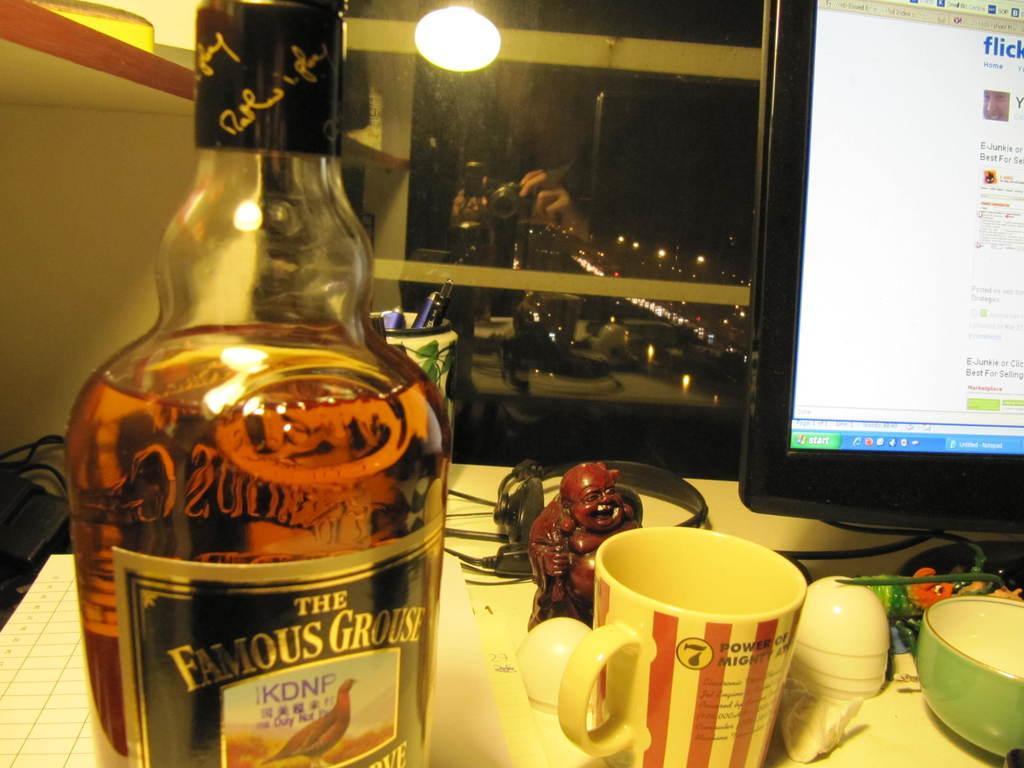Describe this image in one or two sentences. In this image, we can see a table. On top of the table, there is a bottle. That is filled with liquid. There is a sticker on it. Toy, cup ,bowl here we can see headphones. On the right side of the image, we can see monitor screen. On the left side, we can see few wires. At the background, we can see some lights. Here we can see camera that is holded by a human. Here we can see pen stand with pens. 